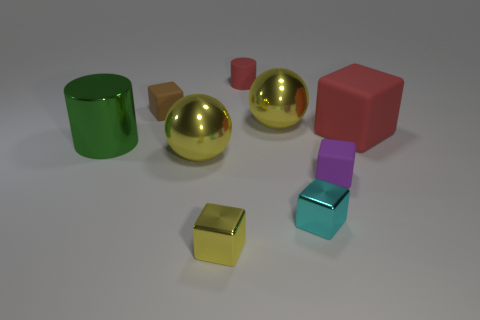Subtract all blue cubes. Subtract all brown cylinders. How many cubes are left? 5 Add 1 large green cylinders. How many objects exist? 10 Subtract all cylinders. How many objects are left? 7 Add 8 tiny rubber cylinders. How many tiny rubber cylinders are left? 9 Add 3 cyan objects. How many cyan objects exist? 4 Subtract 0 brown cylinders. How many objects are left? 9 Subtract all small metallic cubes. Subtract all big green cylinders. How many objects are left? 6 